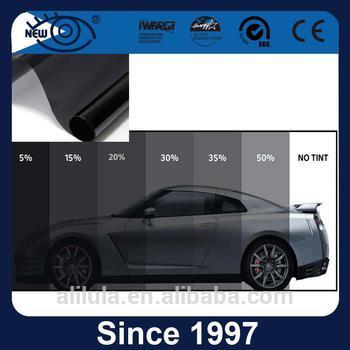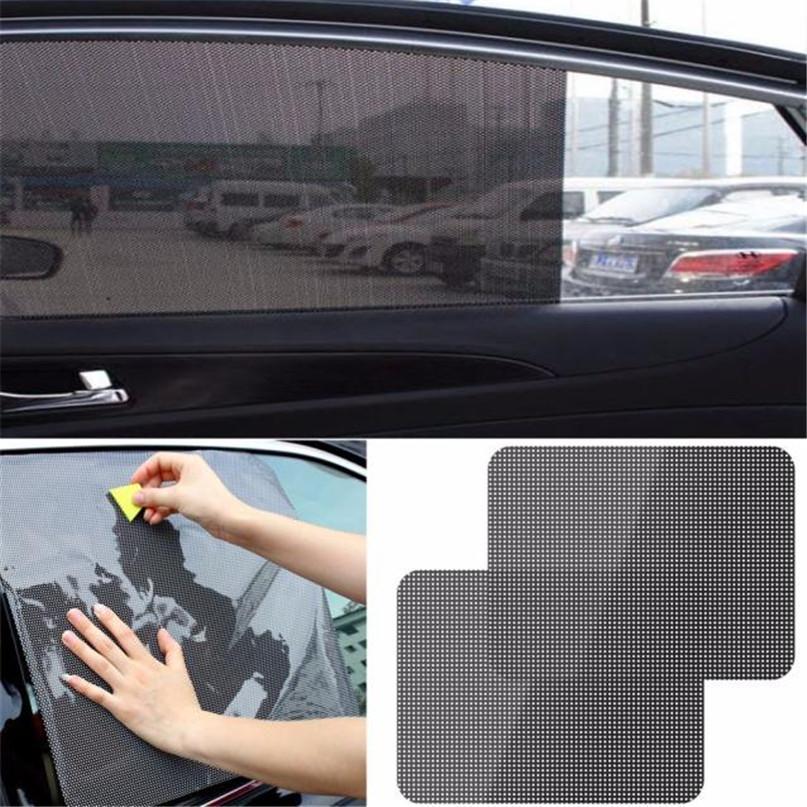The first image is the image on the left, the second image is the image on the right. Examine the images to the left and right. Is the description "There are a pair of hands with the right hand splayed out and the left balled up." accurate? Answer yes or no. No. 